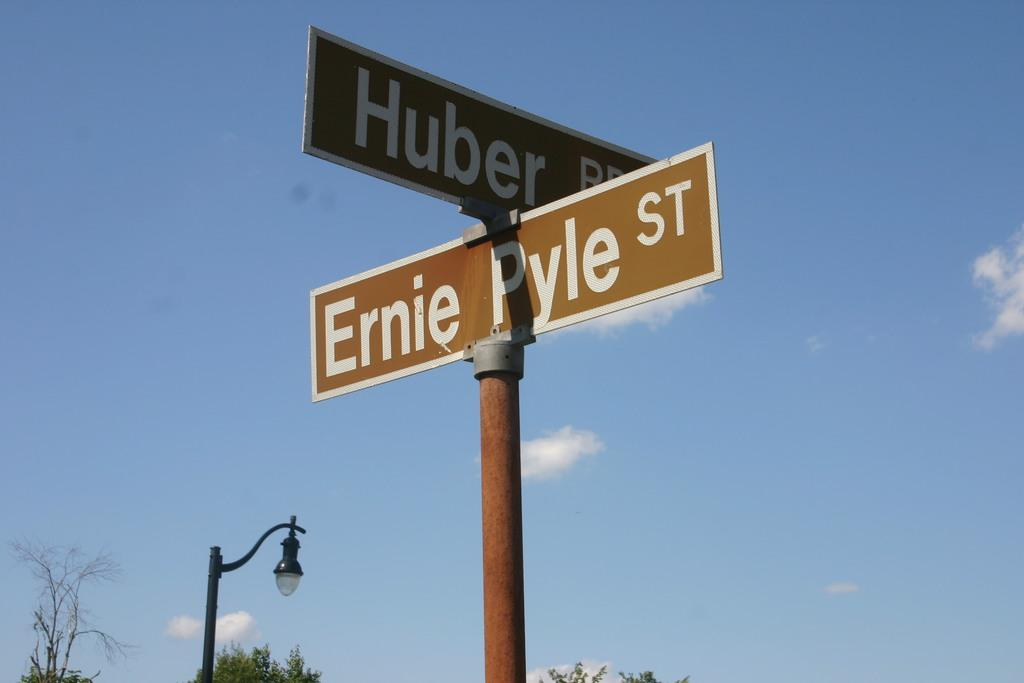What can be seen in the middle of the image? There are poles and sign boards in the middle of the image. What is visible in the background of the image? There are trees visible in the background of the image. What can be seen in the sky at the top of the image? There are clouds in the sky at the top of the image. Are there any trains passing through the cemetery in the image? There is no cemetery or trains present in the image. What type of yard is visible in the image? There is no yard visible in the image. 